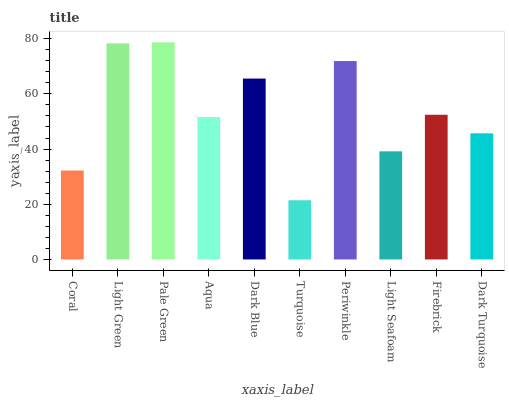Is Turquoise the minimum?
Answer yes or no. Yes. Is Pale Green the maximum?
Answer yes or no. Yes. Is Light Green the minimum?
Answer yes or no. No. Is Light Green the maximum?
Answer yes or no. No. Is Light Green greater than Coral?
Answer yes or no. Yes. Is Coral less than Light Green?
Answer yes or no. Yes. Is Coral greater than Light Green?
Answer yes or no. No. Is Light Green less than Coral?
Answer yes or no. No. Is Firebrick the high median?
Answer yes or no. Yes. Is Aqua the low median?
Answer yes or no. Yes. Is Aqua the high median?
Answer yes or no. No. Is Periwinkle the low median?
Answer yes or no. No. 